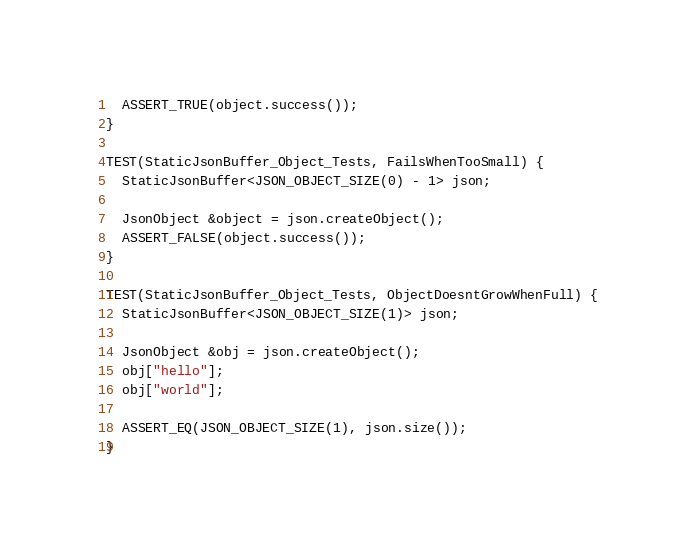<code> <loc_0><loc_0><loc_500><loc_500><_C++_>  ASSERT_TRUE(object.success());
}

TEST(StaticJsonBuffer_Object_Tests, FailsWhenTooSmall) {
  StaticJsonBuffer<JSON_OBJECT_SIZE(0) - 1> json;

  JsonObject &object = json.createObject();
  ASSERT_FALSE(object.success());
}

TEST(StaticJsonBuffer_Object_Tests, ObjectDoesntGrowWhenFull) {
  StaticJsonBuffer<JSON_OBJECT_SIZE(1)> json;

  JsonObject &obj = json.createObject();
  obj["hello"];
  obj["world"];

  ASSERT_EQ(JSON_OBJECT_SIZE(1), json.size());
}
</code> 